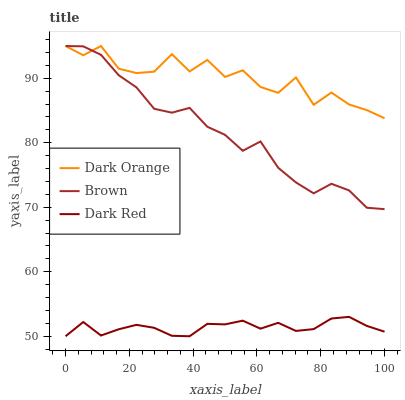Does Dark Red have the minimum area under the curve?
Answer yes or no. Yes. Does Dark Orange have the maximum area under the curve?
Answer yes or no. Yes. Does Brown have the minimum area under the curve?
Answer yes or no. No. Does Brown have the maximum area under the curve?
Answer yes or no. No. Is Dark Red the smoothest?
Answer yes or no. Yes. Is Dark Orange the roughest?
Answer yes or no. Yes. Is Brown the smoothest?
Answer yes or no. No. Is Brown the roughest?
Answer yes or no. No. Does Dark Red have the lowest value?
Answer yes or no. Yes. Does Brown have the lowest value?
Answer yes or no. No. Does Brown have the highest value?
Answer yes or no. Yes. Does Dark Red have the highest value?
Answer yes or no. No. Is Dark Red less than Dark Orange?
Answer yes or no. Yes. Is Brown greater than Dark Red?
Answer yes or no. Yes. Does Brown intersect Dark Orange?
Answer yes or no. Yes. Is Brown less than Dark Orange?
Answer yes or no. No. Is Brown greater than Dark Orange?
Answer yes or no. No. Does Dark Red intersect Dark Orange?
Answer yes or no. No. 